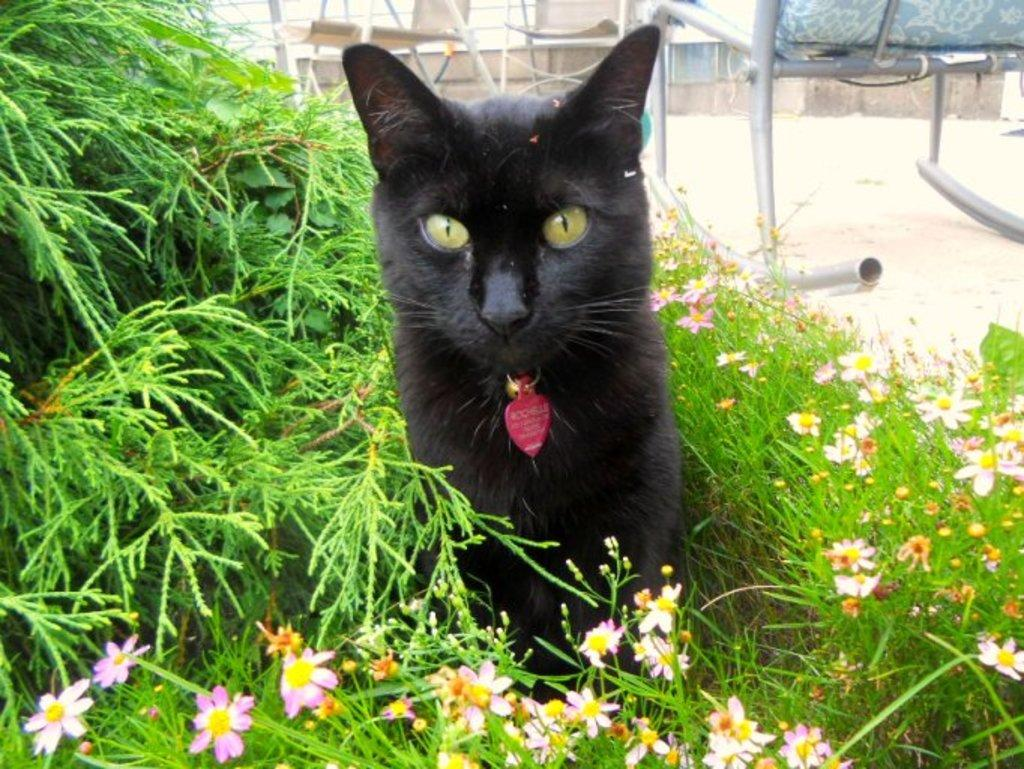What type of animal is in the image? There is a black cat in the image. Where is the black cat located? The black cat is sitting in the flower plants. How many snakes are slithering through the alley in the image? There are no snakes or alleys present in the image; it features a black cat sitting in flower plants. 